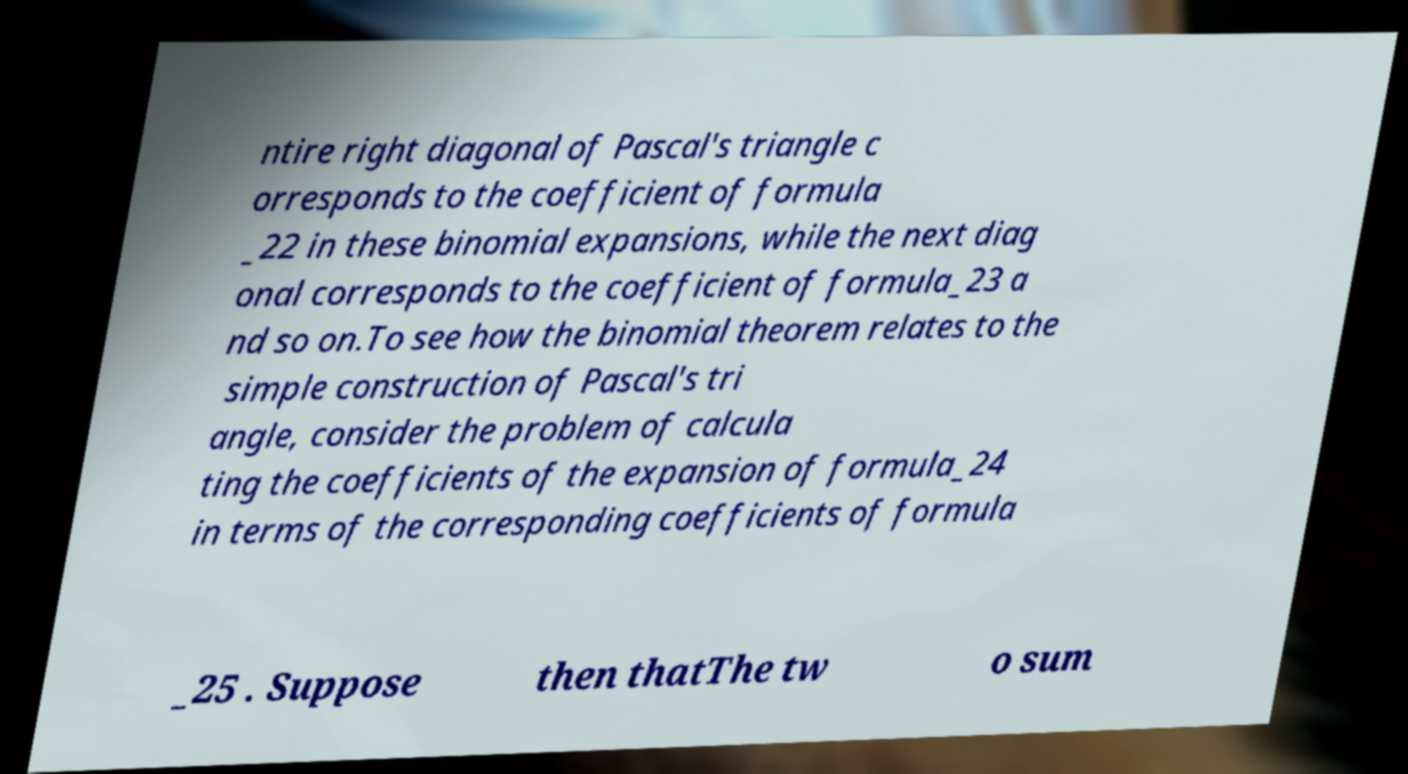Please identify and transcribe the text found in this image. ntire right diagonal of Pascal's triangle c orresponds to the coefficient of formula _22 in these binomial expansions, while the next diag onal corresponds to the coefficient of formula_23 a nd so on.To see how the binomial theorem relates to the simple construction of Pascal's tri angle, consider the problem of calcula ting the coefficients of the expansion of formula_24 in terms of the corresponding coefficients of formula _25 . Suppose then thatThe tw o sum 